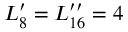<formula> <loc_0><loc_0><loc_500><loc_500>L _ { 8 } ^ { \prime } = L _ { 1 6 } ^ { \prime \prime } = 4</formula> 